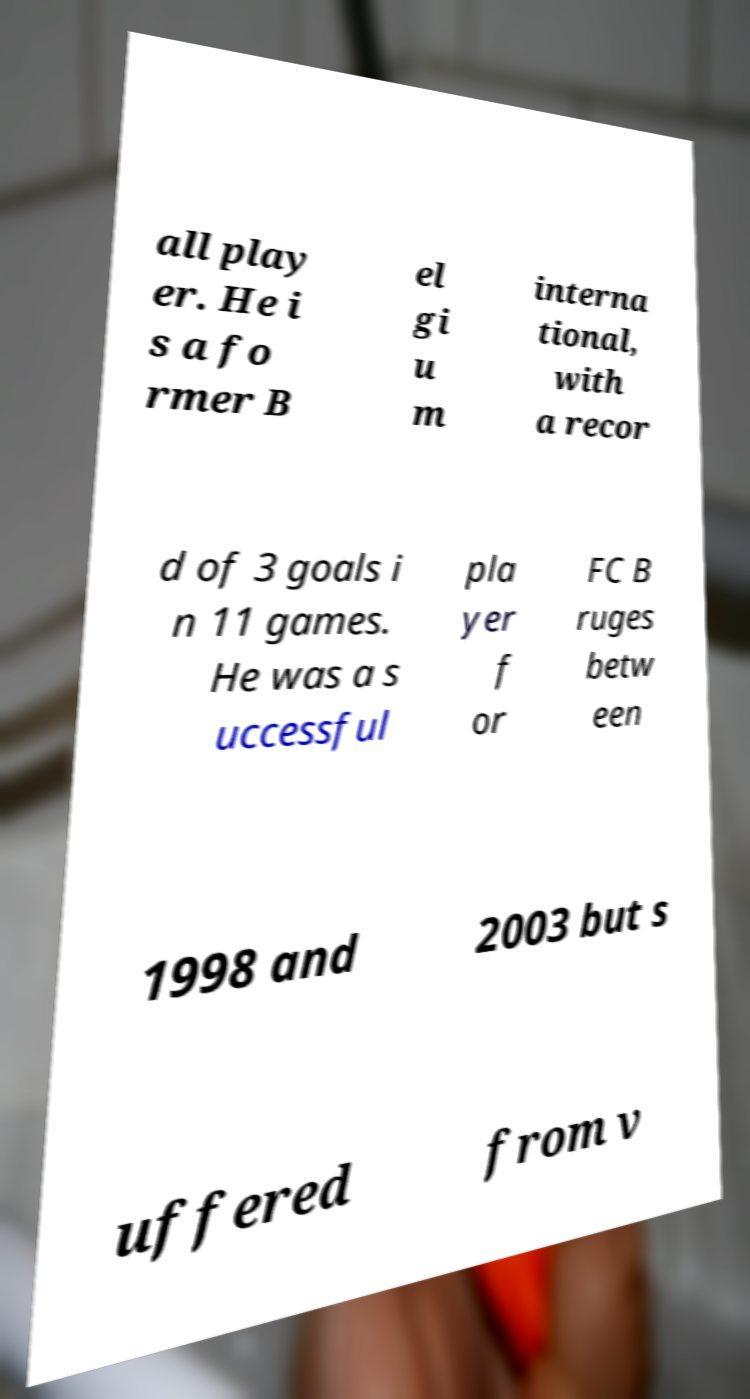For documentation purposes, I need the text within this image transcribed. Could you provide that? all play er. He i s a fo rmer B el gi u m interna tional, with a recor d of 3 goals i n 11 games. He was a s uccessful pla yer f or FC B ruges betw een 1998 and 2003 but s uffered from v 